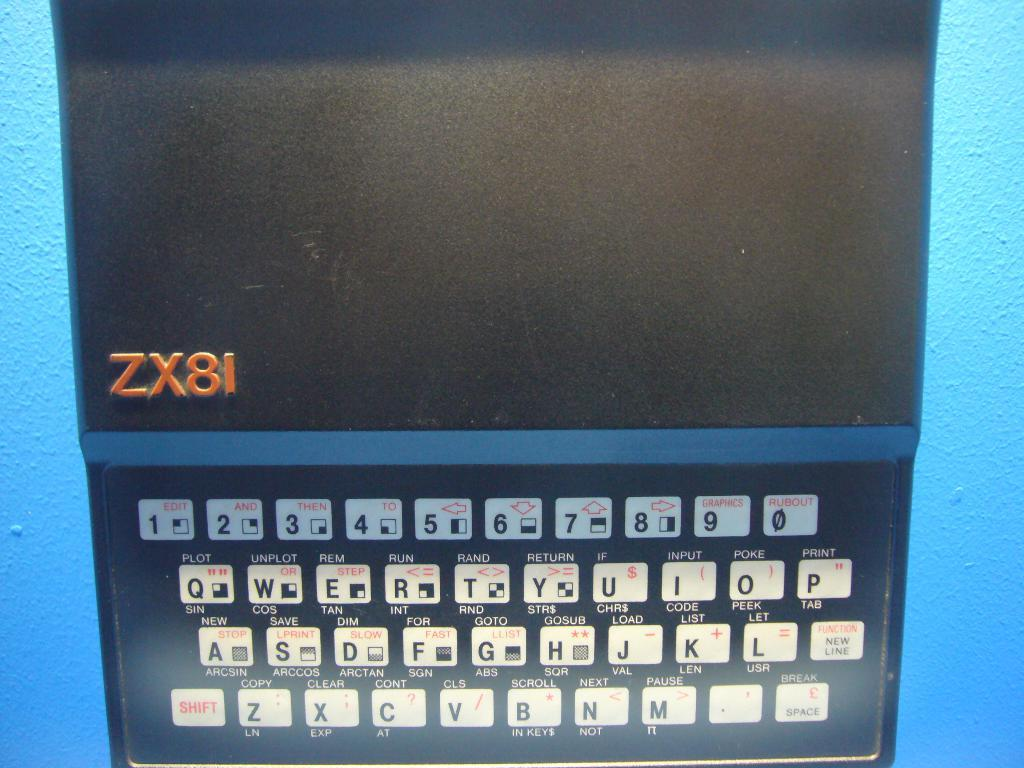Provide a one-sentence caption for the provided image. a computer keyboard with ZX8I written above the keys. 